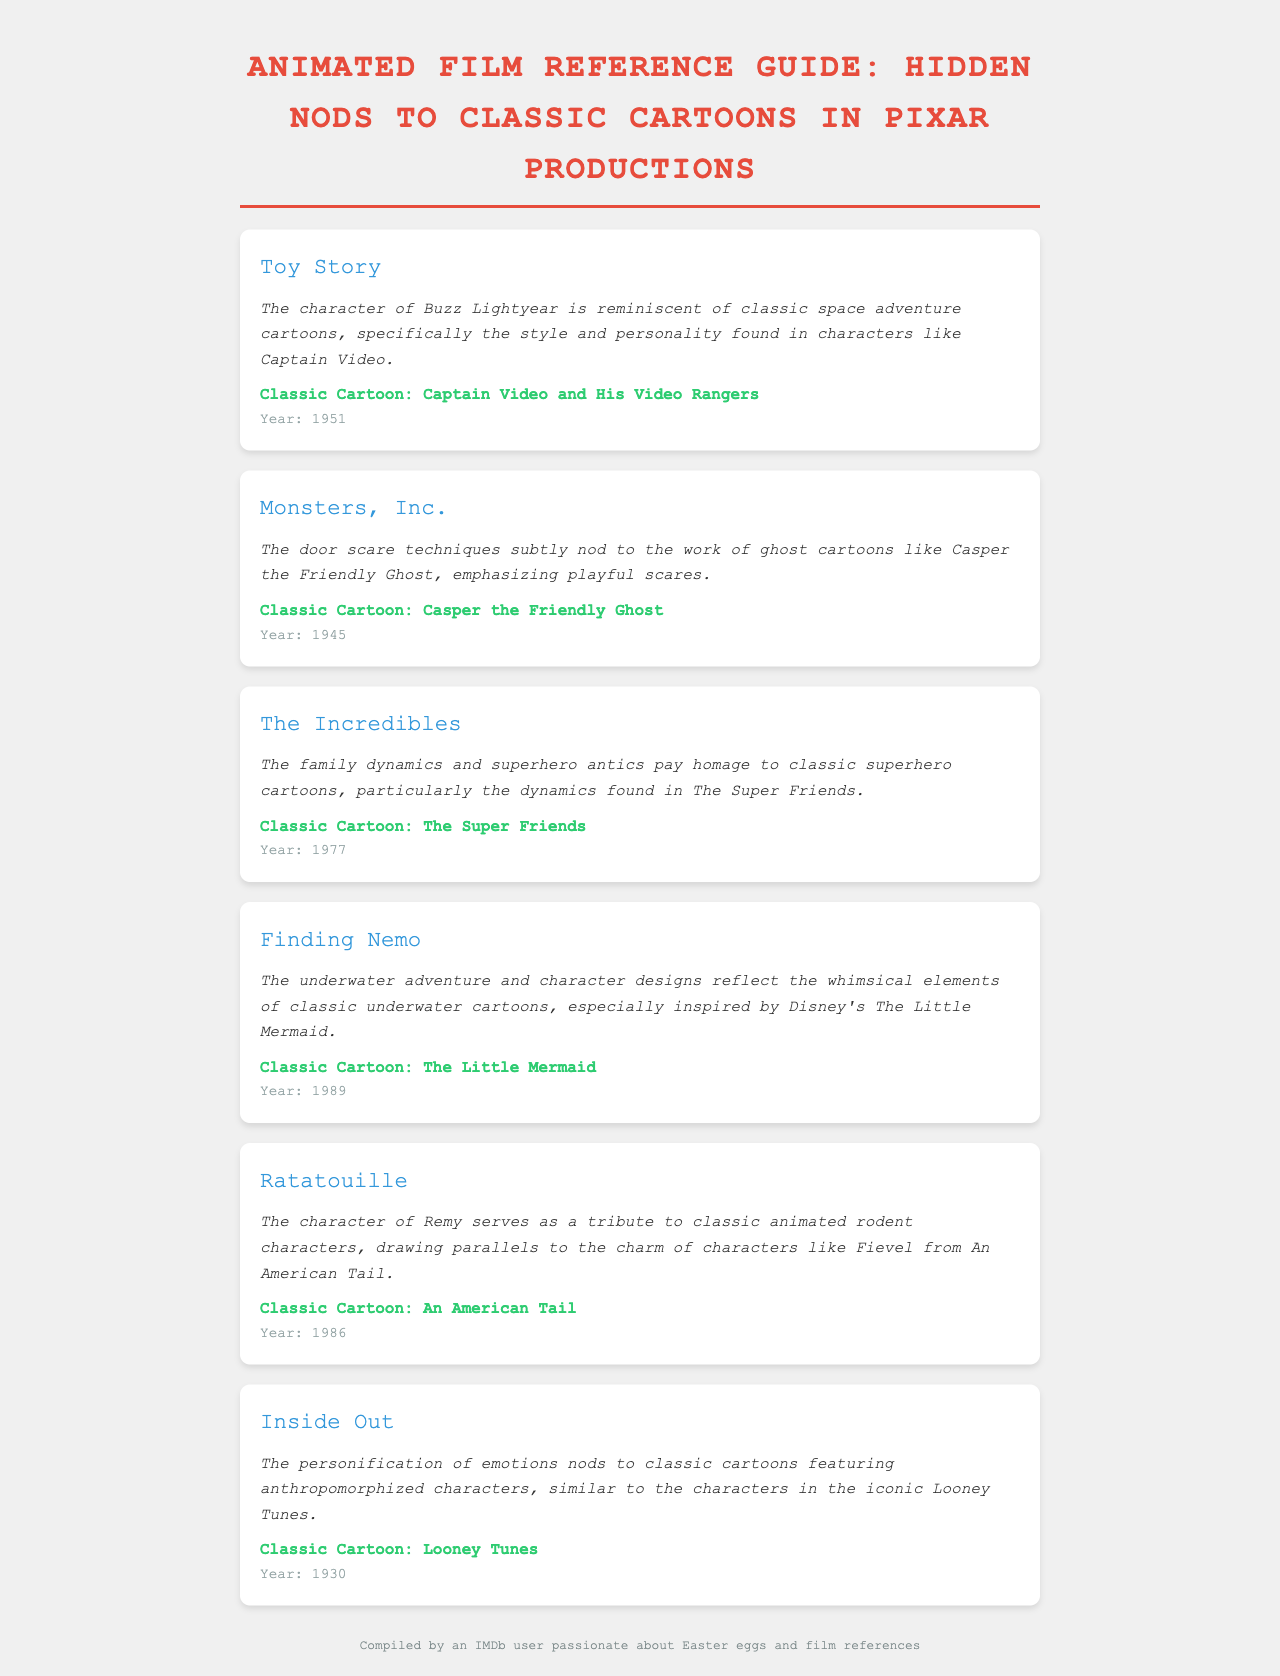What is the classic cartoon referenced in Toy Story? The document lists that Toy Story references Captain Video and His Video Rangers as the classic cartoon.
Answer: Captain Video and His Video Rangers Which Pixar film features a nod to Casper the Friendly Ghost? The reference section indicates that Monsters, Inc. features a nod to this classic cartoon.
Answer: Monsters, Inc What is the year of release for The Incredibles? The document provides the year 1977 for the classic cartoon it references.
Answer: 1977 Which classic cartoon inspired the underwater designs in Finding Nemo? The document states that Finding Nemo is inspired by Disney's The Little Mermaid.
Answer: The Little Mermaid Who is the character in Ratatouille that pays tribute to classic animated rodents? The document mentions that Remy serves as this tribute character in Ratatouille.
Answer: Remy What type of characters are personified in Inside Out? The reference speaks about anthropomorphized characters as central to Inside Out.
Answer: Emotions Which Pixar film showcases superhero dynamics reminiscent of The Super Friends? The Incredibles is mentioned as showcasing these dynamics in the document.
Answer: The Incredibles What type of humor is depicted through the door scare techniques in Monsters, Inc.? The humor is described as playful scares, indicating a lighthearted approach.
Answer: Playful scares 